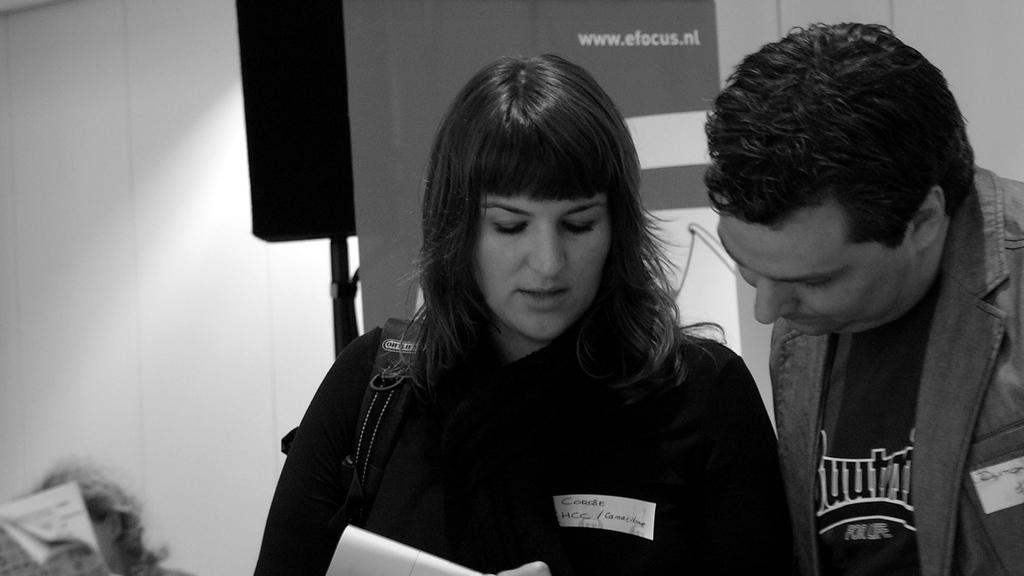<image>
Create a compact narrative representing the image presented. a man and lady talking in front of a efocus ad 